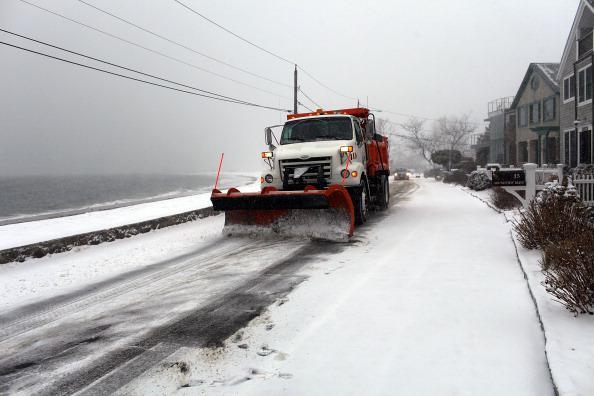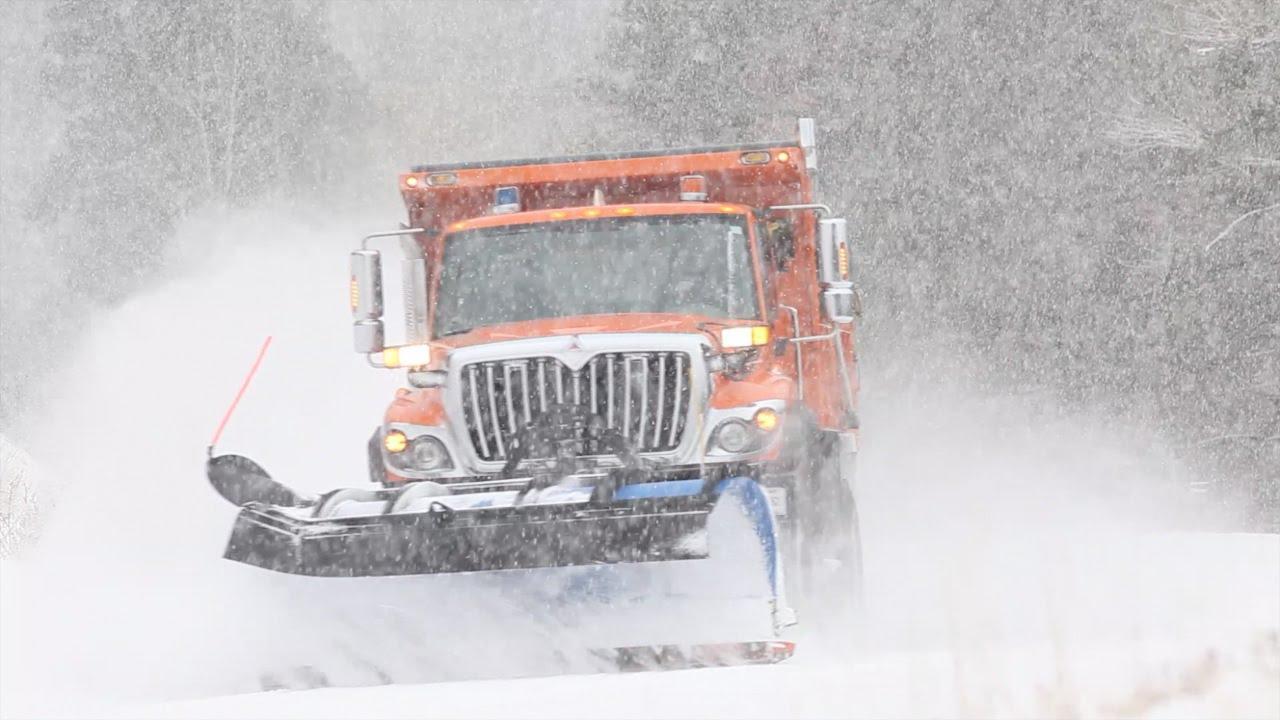The first image is the image on the left, the second image is the image on the right. Evaluate the accuracy of this statement regarding the images: "There is exactly one yellow truck on the image.". Is it true? Answer yes or no. No. 